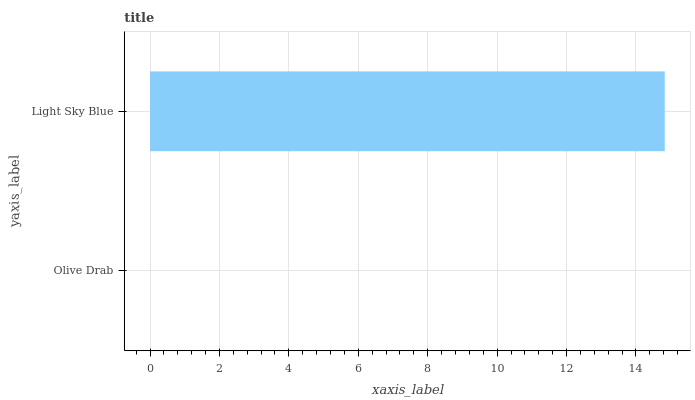Is Olive Drab the minimum?
Answer yes or no. Yes. Is Light Sky Blue the maximum?
Answer yes or no. Yes. Is Light Sky Blue the minimum?
Answer yes or no. No. Is Light Sky Blue greater than Olive Drab?
Answer yes or no. Yes. Is Olive Drab less than Light Sky Blue?
Answer yes or no. Yes. Is Olive Drab greater than Light Sky Blue?
Answer yes or no. No. Is Light Sky Blue less than Olive Drab?
Answer yes or no. No. Is Light Sky Blue the high median?
Answer yes or no. Yes. Is Olive Drab the low median?
Answer yes or no. Yes. Is Olive Drab the high median?
Answer yes or no. No. Is Light Sky Blue the low median?
Answer yes or no. No. 